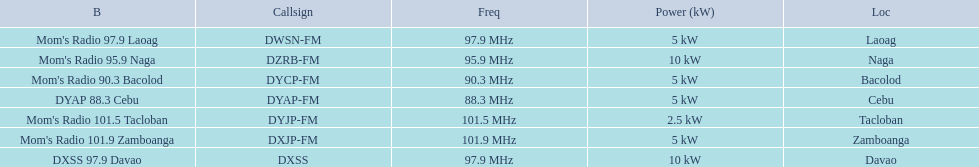What is the power capacity in kw for each team? 5 kW, 10 kW, 5 kW, 5 kW, 2.5 kW, 5 kW, 10 kW. Which is the lowest? 2.5 kW. What station has this amount of power? Mom's Radio 101.5 Tacloban. 